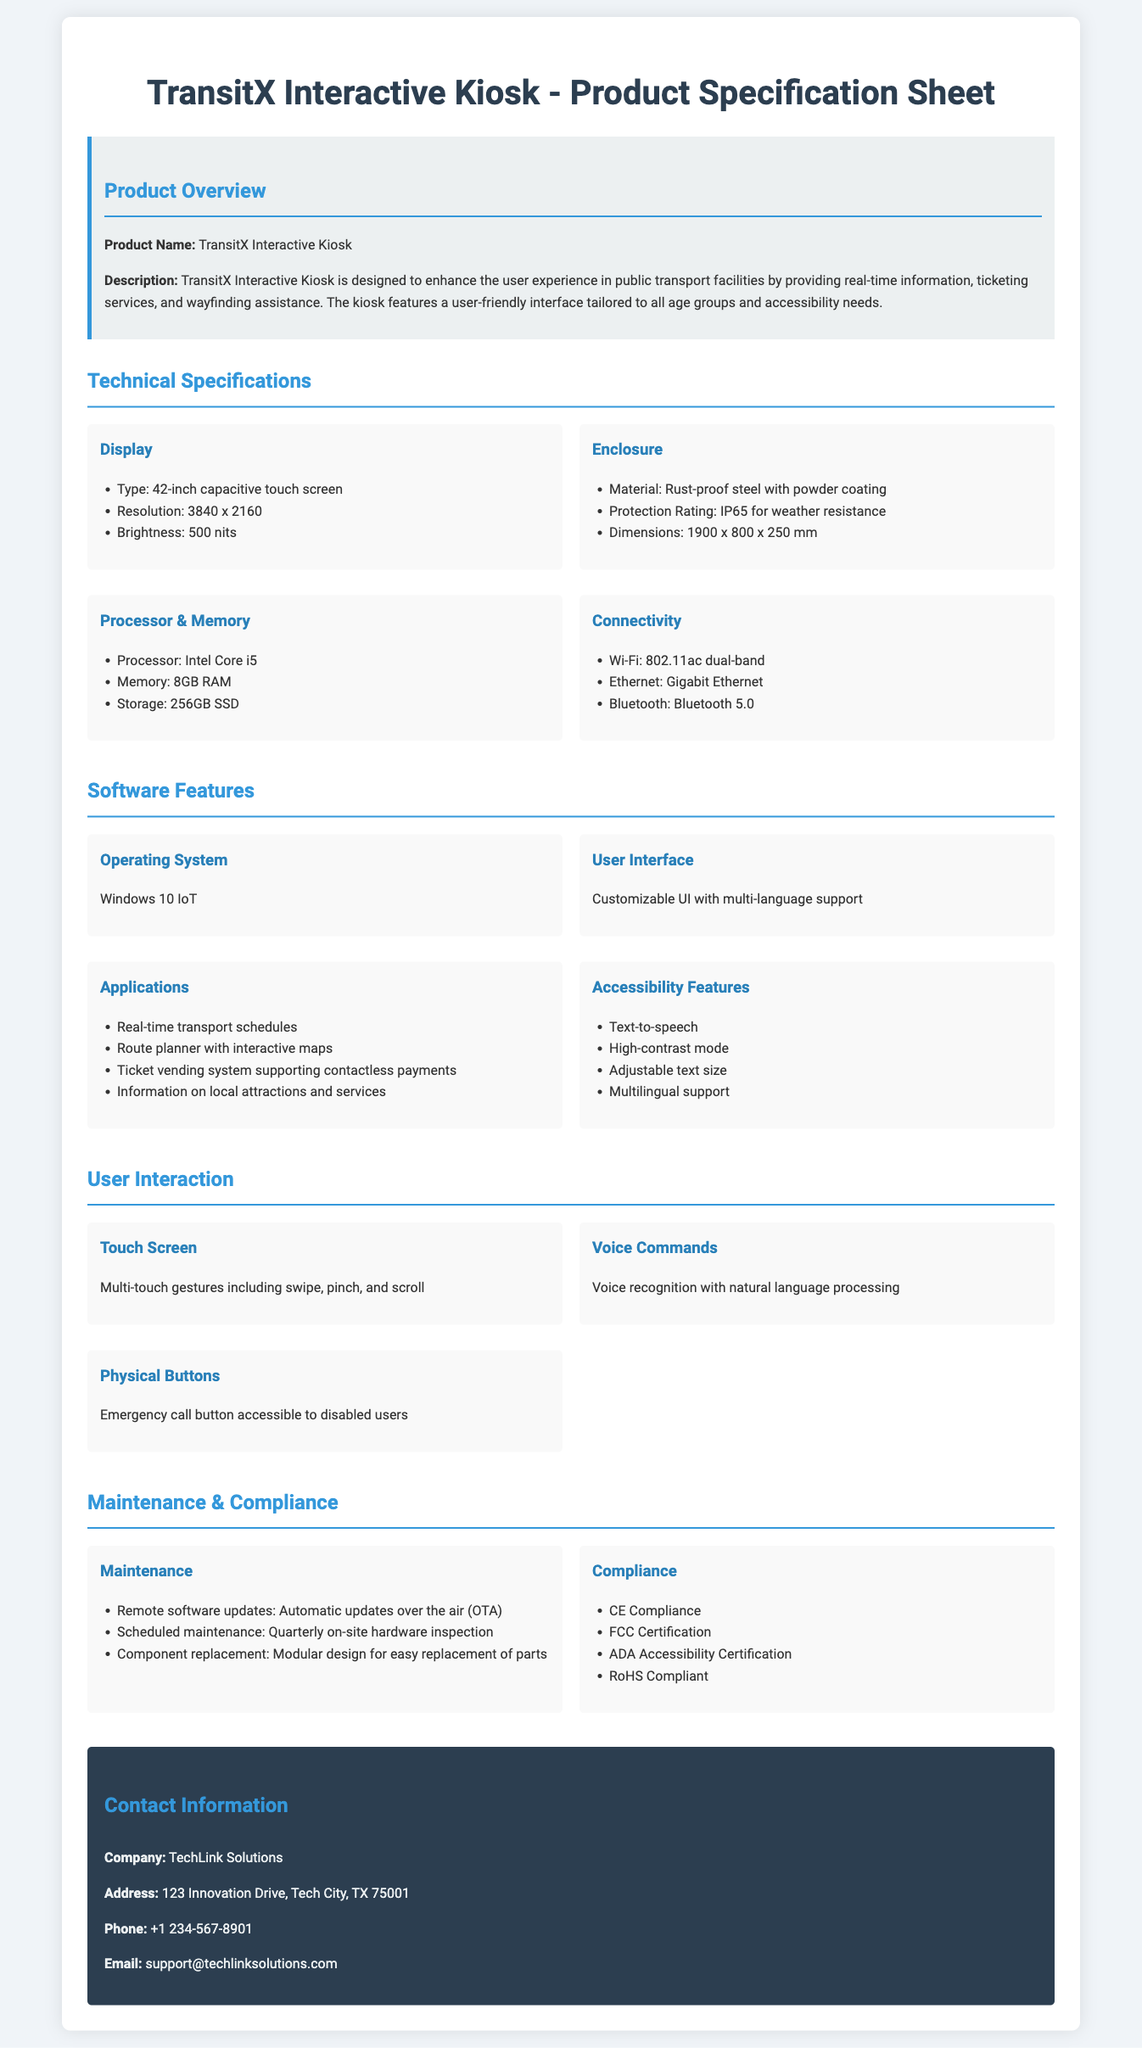What is the product name? The product name is mentioned in the title section of the document.
Answer: TransitX Interactive Kiosk What is the display type of the kiosk? The display details are provided under the technical specifications section.
Answer: 42-inch capacitive touch screen What is the resolution of the display? The resolution is stated in the specifications for the display in the document.
Answer: 3840 x 2160 What operating system does the kiosk use? The operating system is specified in the software features section.
Answer: Windows 10 IoT What is the protection rating of the enclosure? The protection rating is listed under the enclosure specifications.
Answer: IP65 How many languages does the user interface support? The document mentions multi-language support under user interface features.
Answer: Multiple What is the processor type in the kiosk? The processor details are included in the technical specifications section.
Answer: Intel Core i5 What maintenance feature allows for remote updates? The document specifies this under maintenance features.
Answer: Automatic updates over the air (OTA) Does the kiosk have a voice command feature? The user interaction section describes the functionalities available, including voice commands.
Answer: Yes 